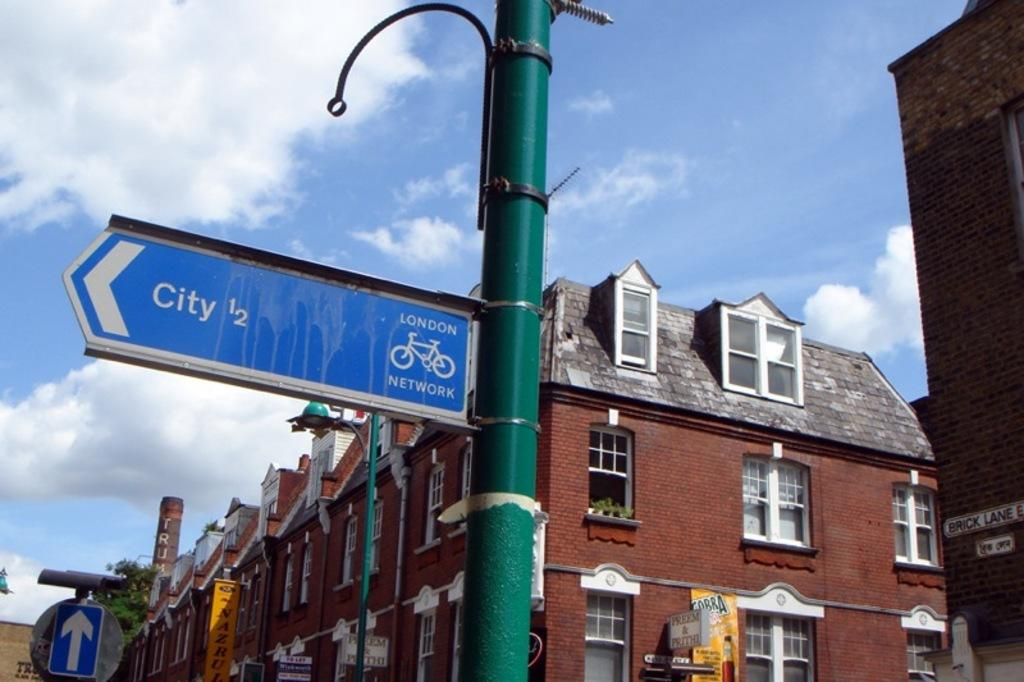What type of objects can be seen in the image with text or information on them? There are signboards, banners, and name boards in the image with text or information on them. What type of structures are visible in the image? There are buildings with windows in the image. What type of vertical structures can be seen in the image? There are poles in the image. What type of vegetation is present in the image? There are house plants and trees in the image. What can be seen in the background of the image? The sky with clouds is visible in the background of the image. What type of beef is being used to hold up the banners in the image? There is no beef present in the image; the banners are held up by poles or other structures. What type of glue is being used to attach the name boards to the buildings in the image? There is no information about glue in the image; the name boards are attached to the buildings in some other manner. 